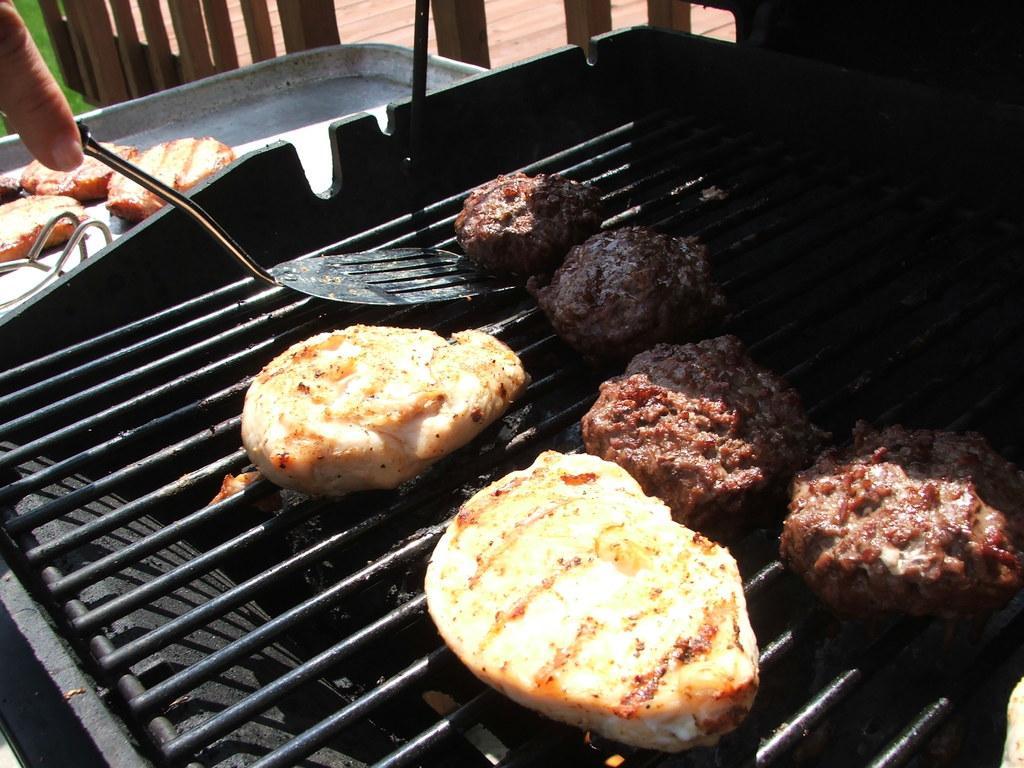How would you summarize this image in a sentence or two? In this picture I can see food on the grill and I can see serving spoon in the human hand and I can see some food in the tray and looks like couple of wooden chairs in the back. 